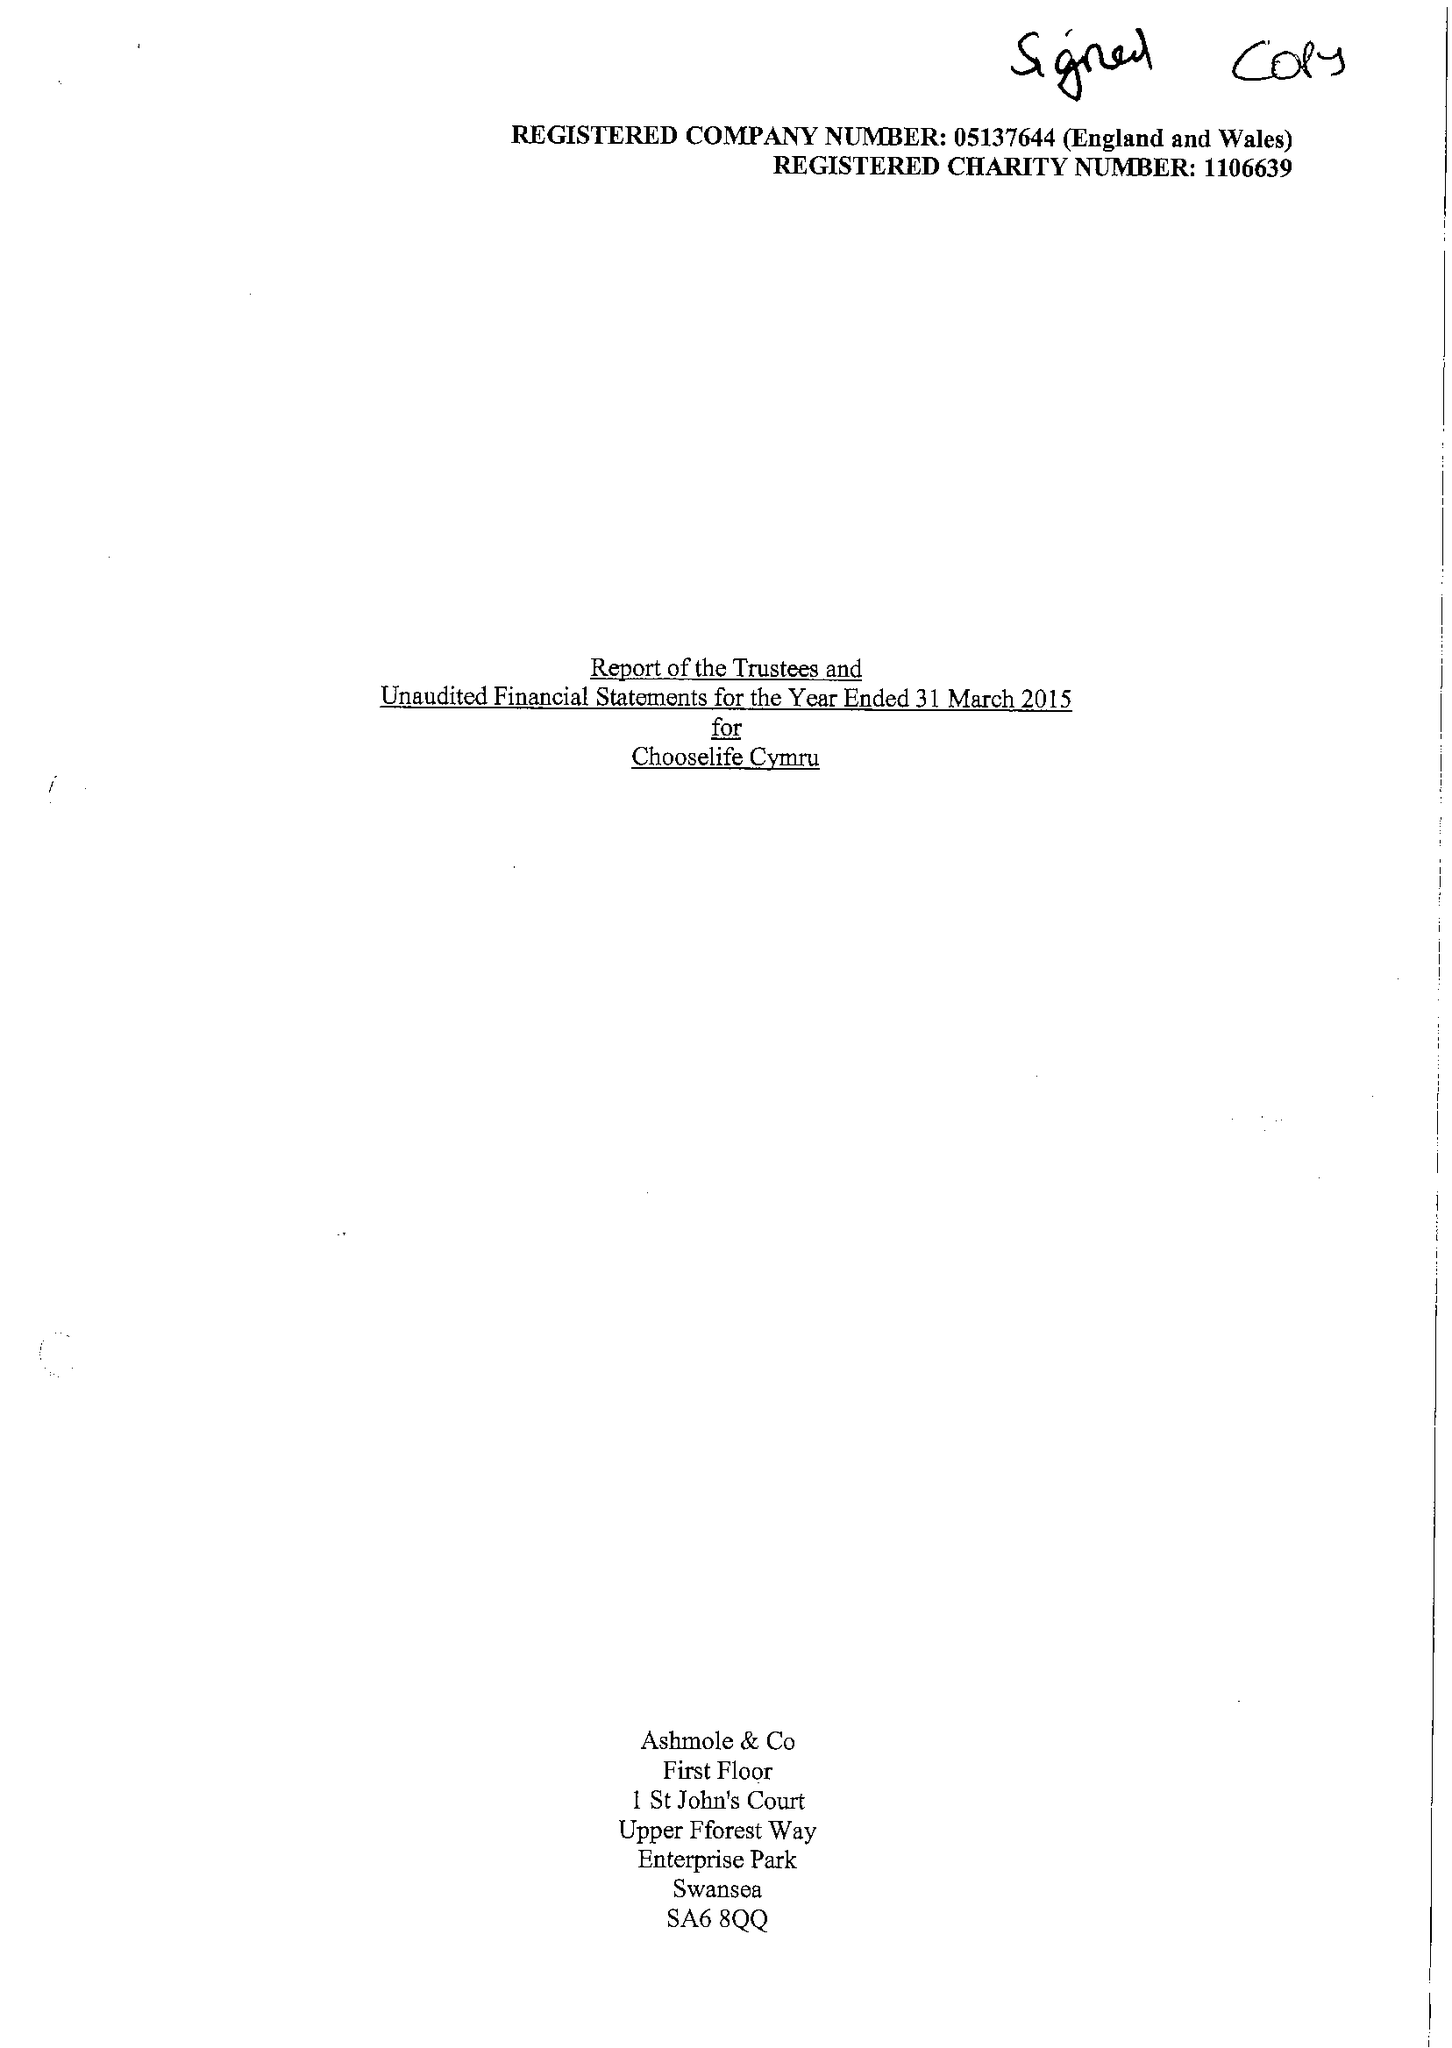What is the value for the report_date?
Answer the question using a single word or phrase. 2015-03-31 